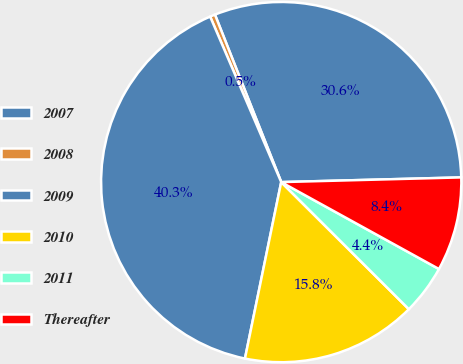Convert chart. <chart><loc_0><loc_0><loc_500><loc_500><pie_chart><fcel>2007<fcel>2008<fcel>2009<fcel>2010<fcel>2011<fcel>Thereafter<nl><fcel>30.58%<fcel>0.46%<fcel>40.32%<fcel>15.76%<fcel>4.45%<fcel>8.43%<nl></chart> 